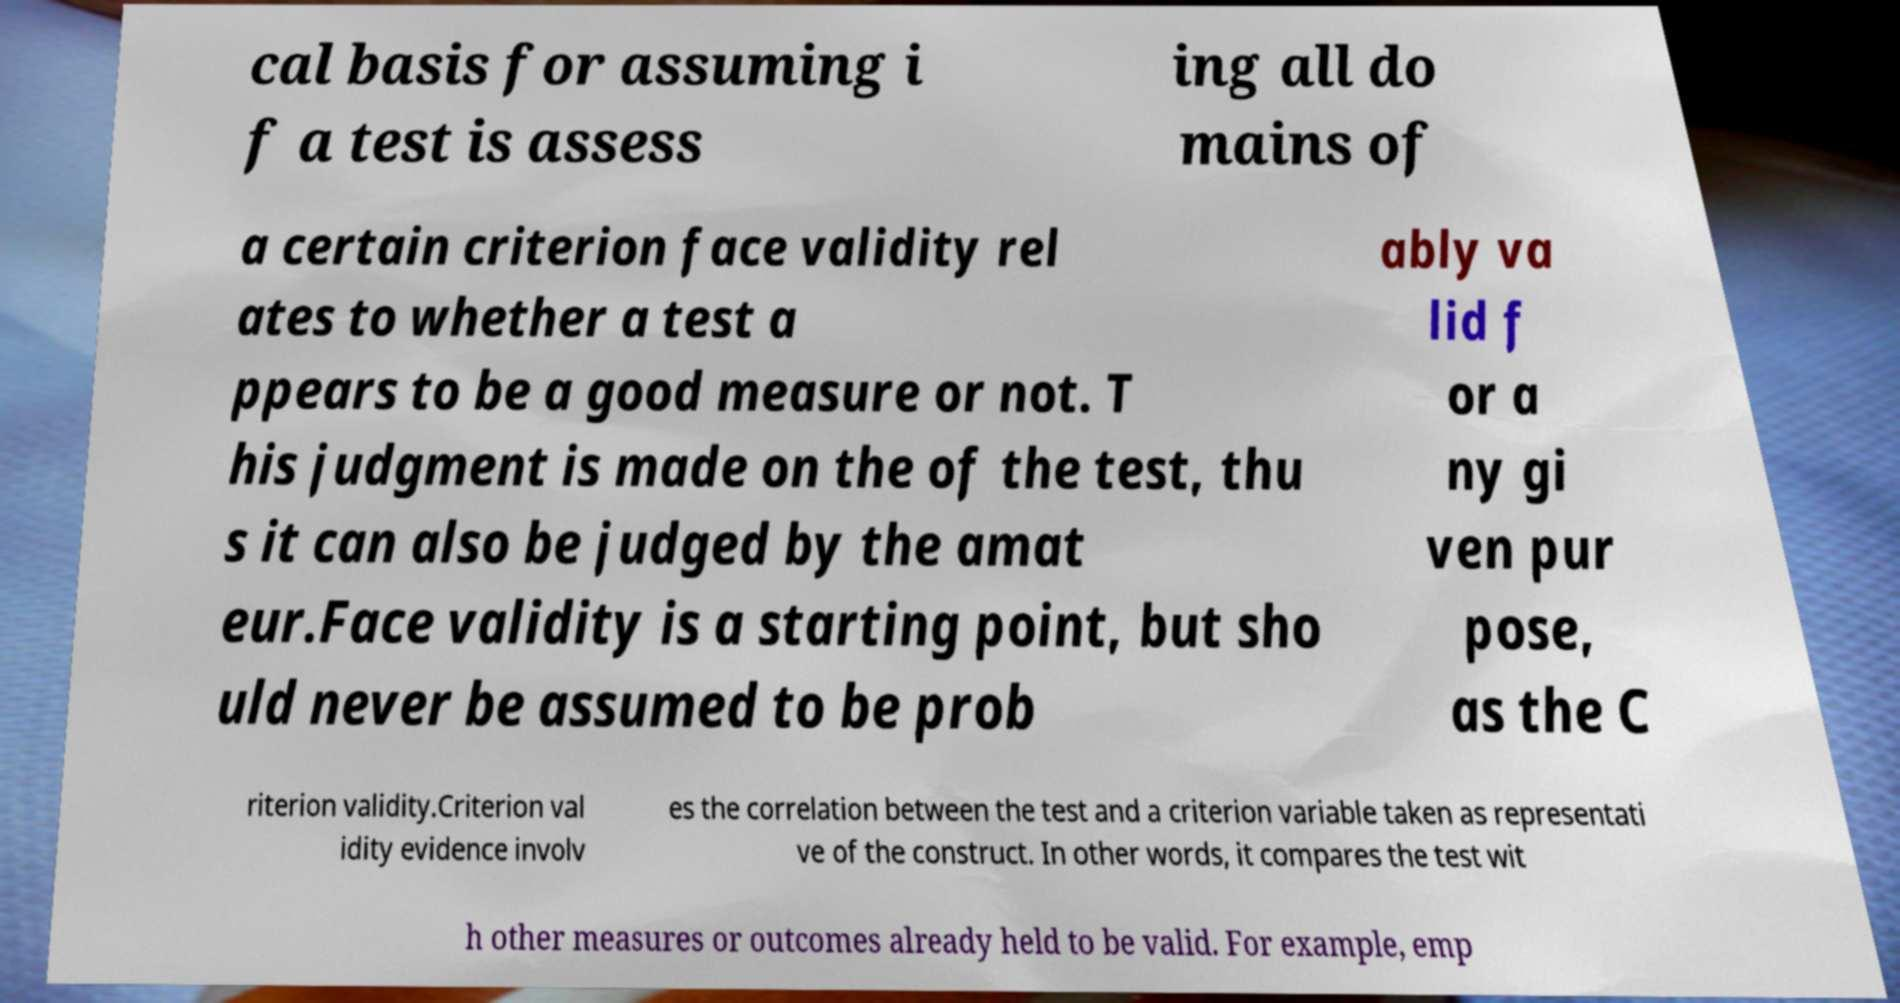For documentation purposes, I need the text within this image transcribed. Could you provide that? cal basis for assuming i f a test is assess ing all do mains of a certain criterion face validity rel ates to whether a test a ppears to be a good measure or not. T his judgment is made on the of the test, thu s it can also be judged by the amat eur.Face validity is a starting point, but sho uld never be assumed to be prob ably va lid f or a ny gi ven pur pose, as the C riterion validity.Criterion val idity evidence involv es the correlation between the test and a criterion variable taken as representati ve of the construct. In other words, it compares the test wit h other measures or outcomes already held to be valid. For example, emp 